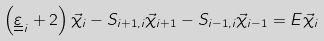Convert formula to latex. <formula><loc_0><loc_0><loc_500><loc_500>\left ( \underline { \underline { \varepsilon } } _ { \, i } + 2 \right ) { \vec { \chi } } _ { i } - S _ { i + 1 , i } { \vec { \chi } } _ { i + 1 } - S _ { i - 1 , i } { \vec { \chi } } _ { i - 1 } = E { \vec { \chi } } _ { i }</formula> 